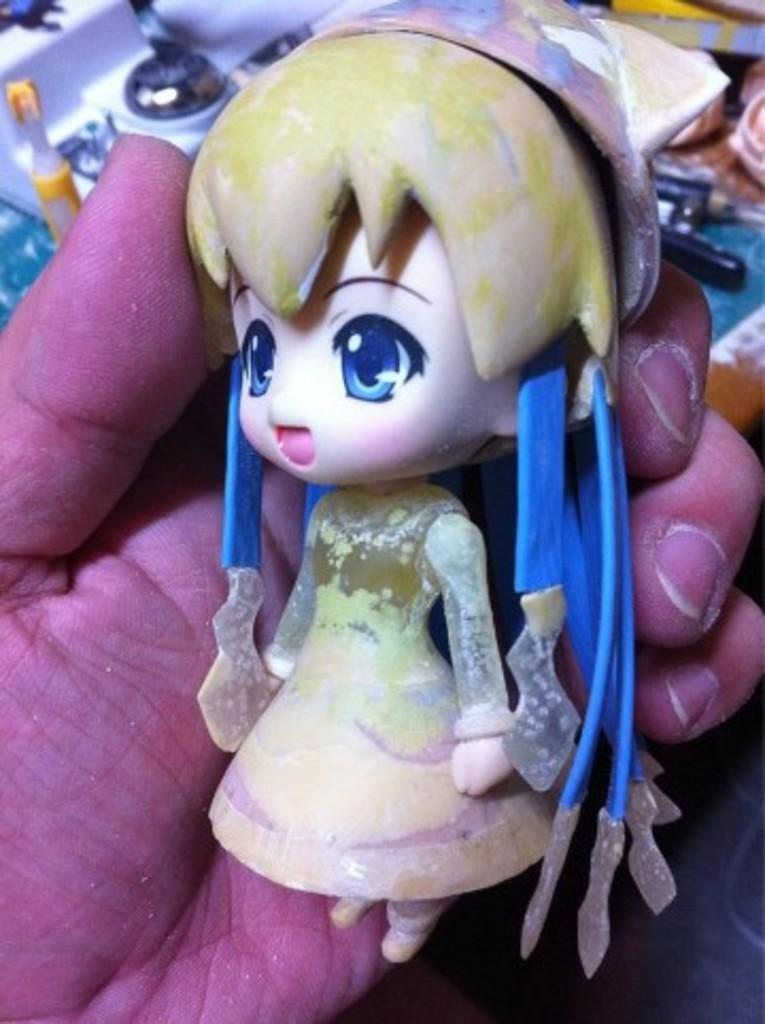What is the person holding in the image? The person is holding a doll in the image. How is the doll being held? The doll is being held by a hand in the image. What can be seen on the table in the image? There is a table in the image with paste, scissors, chocolate, papers, a mat, and other objects on it. What type of glove is being used to hold the stem in the image? There is no glove or stem present in the image. 